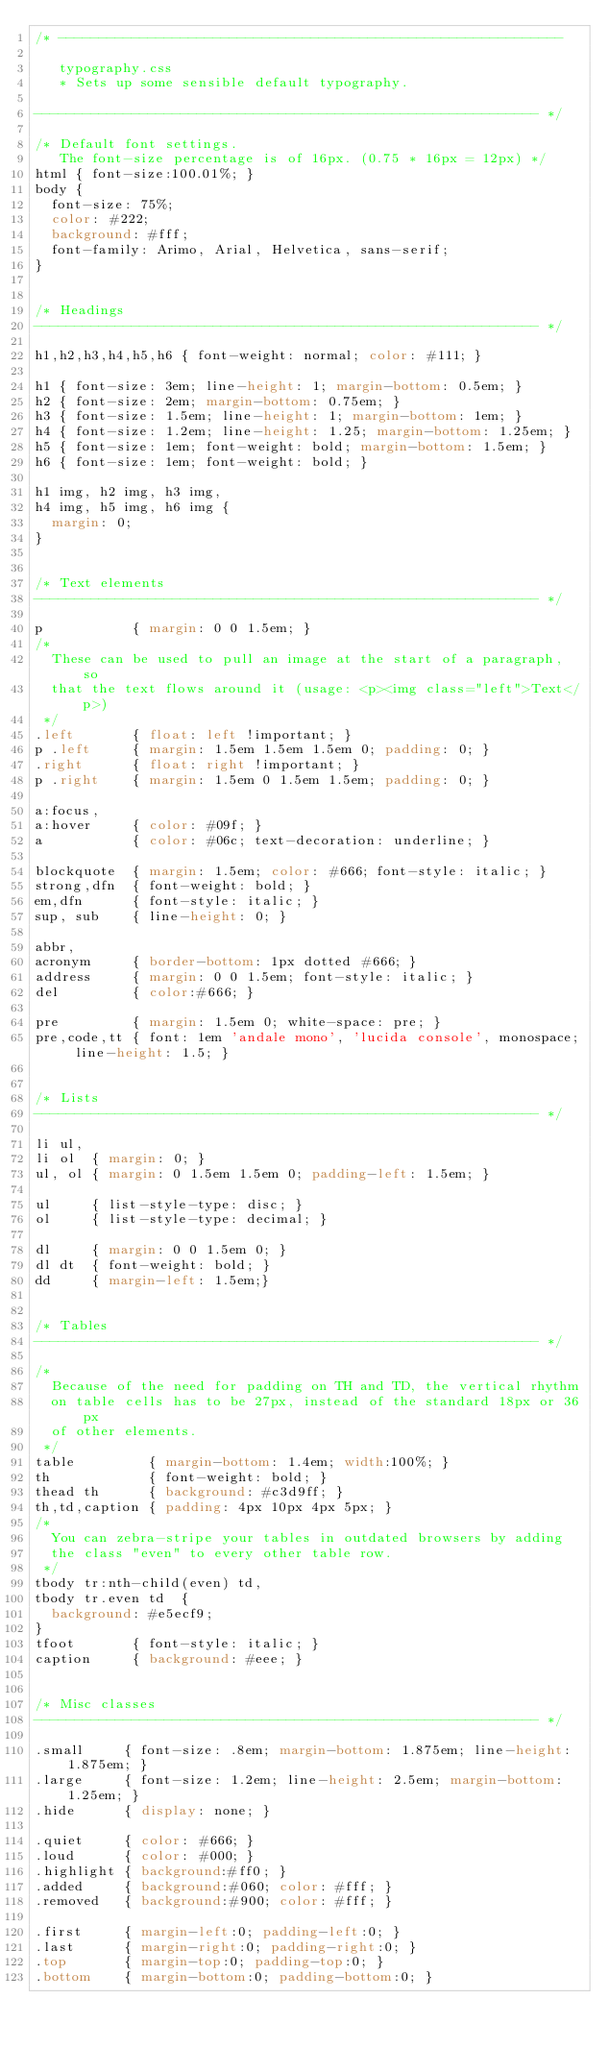Convert code to text. <code><loc_0><loc_0><loc_500><loc_500><_CSS_>/* --------------------------------------------------------------

   typography.css
   * Sets up some sensible default typography.

-------------------------------------------------------------- */

/* Default font settings.
   The font-size percentage is of 16px. (0.75 * 16px = 12px) */
html { font-size:100.01%; }
body {
  font-size: 75%;
  color: #222;
  background: #fff;
  font-family: Arimo, Arial, Helvetica, sans-serif;
}


/* Headings
-------------------------------------------------------------- */

h1,h2,h3,h4,h5,h6 { font-weight: normal; color: #111; }

h1 { font-size: 3em; line-height: 1; margin-bottom: 0.5em; }
h2 { font-size: 2em; margin-bottom: 0.75em; }
h3 { font-size: 1.5em; line-height: 1; margin-bottom: 1em; }
h4 { font-size: 1.2em; line-height: 1.25; margin-bottom: 1.25em; }
h5 { font-size: 1em; font-weight: bold; margin-bottom: 1.5em; }
h6 { font-size: 1em; font-weight: bold; }

h1 img, h2 img, h3 img,
h4 img, h5 img, h6 img {
  margin: 0;
}


/* Text elements
-------------------------------------------------------------- */

p           { margin: 0 0 1.5em; }
/*
  These can be used to pull an image at the start of a paragraph, so
  that the text flows around it (usage: <p><img class="left">Text</p>)
 */
.left       { float: left !important; }
p .left     { margin: 1.5em 1.5em 1.5em 0; padding: 0; }
.right      { float: right !important; }
p .right    { margin: 1.5em 0 1.5em 1.5em; padding: 0; }

a:focus,
a:hover     { color: #09f; }
a           { color: #06c; text-decoration: underline; }

blockquote  { margin: 1.5em; color: #666; font-style: italic; }
strong,dfn  { font-weight: bold; }
em,dfn      { font-style: italic; }
sup, sub    { line-height: 0; }

abbr,
acronym     { border-bottom: 1px dotted #666; }
address     { margin: 0 0 1.5em; font-style: italic; }
del         { color:#666; }

pre         { margin: 1.5em 0; white-space: pre; }
pre,code,tt { font: 1em 'andale mono', 'lucida console', monospace; line-height: 1.5; }


/* Lists
-------------------------------------------------------------- */

li ul,
li ol  { margin: 0; }
ul, ol { margin: 0 1.5em 1.5em 0; padding-left: 1.5em; }

ul     { list-style-type: disc; }
ol     { list-style-type: decimal; }

dl     { margin: 0 0 1.5em 0; }
dl dt  { font-weight: bold; }
dd     { margin-left: 1.5em;}


/* Tables
-------------------------------------------------------------- */

/*
  Because of the need for padding on TH and TD, the vertical rhythm
  on table cells has to be 27px, instead of the standard 18px or 36px
  of other elements.
 */
table         { margin-bottom: 1.4em; width:100%; }
th            { font-weight: bold; }
thead th      { background: #c3d9ff; }
th,td,caption { padding: 4px 10px 4px 5px; }
/*
  You can zebra-stripe your tables in outdated browsers by adding
  the class "even" to every other table row.
 */
tbody tr:nth-child(even) td,
tbody tr.even td  {
  background: #e5ecf9;
}
tfoot       { font-style: italic; }
caption     { background: #eee; }


/* Misc classes
-------------------------------------------------------------- */

.small     { font-size: .8em; margin-bottom: 1.875em; line-height: 1.875em; }
.large     { font-size: 1.2em; line-height: 2.5em; margin-bottom: 1.25em; }
.hide      { display: none; }

.quiet     { color: #666; }
.loud      { color: #000; }
.highlight { background:#ff0; }
.added     { background:#060; color: #fff; }
.removed   { background:#900; color: #fff; }

.first     { margin-left:0; padding-left:0; }
.last      { margin-right:0; padding-right:0; }
.top       { margin-top:0; padding-top:0; }
.bottom    { margin-bottom:0; padding-bottom:0; }
</code> 